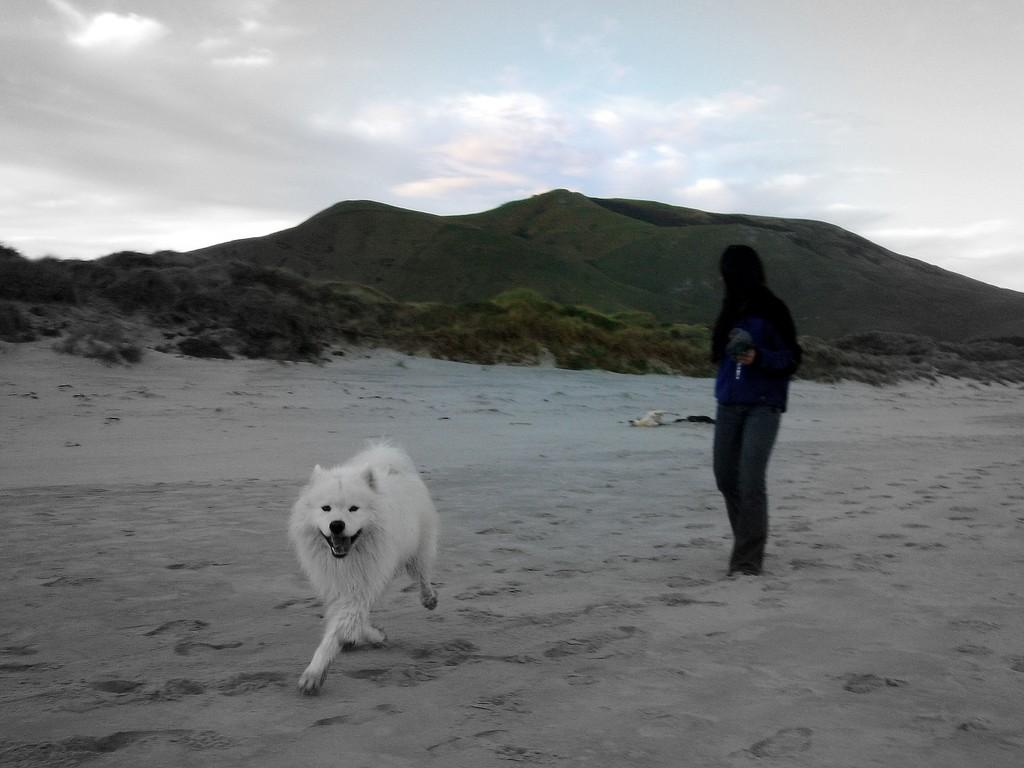What type of animal is in the image? There is a white dog in the image. What is the dog doing in the image? The dog is running. Can you describe the person in the image? There is a person standing in the image. What type of vegetation can be seen in the image? There are plants visible in the image. What is visible in the background of the image? There are mountains in the background of the image. What question is the dog asking in the image? There is no indication in the image that the dog is asking a question. What caused the oven to explode in the image? There is no oven or explosion present in the image. 